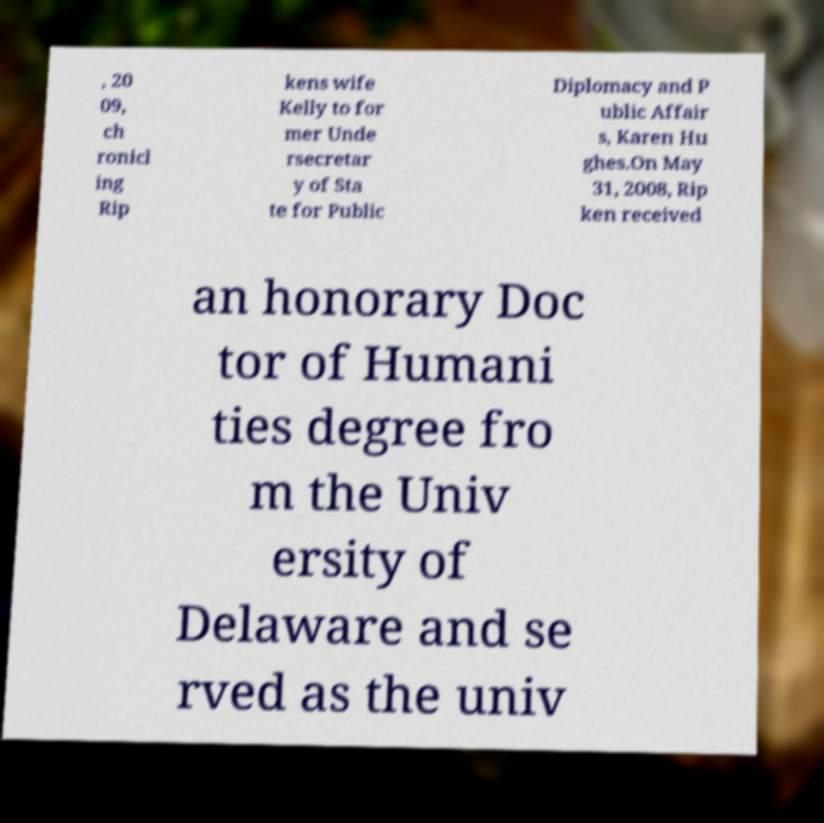For documentation purposes, I need the text within this image transcribed. Could you provide that? , 20 09, ch ronicl ing Rip kens wife Kelly to for mer Unde rsecretar y of Sta te for Public Diplomacy and P ublic Affair s, Karen Hu ghes.On May 31, 2008, Rip ken received an honorary Doc tor of Humani ties degree fro m the Univ ersity of Delaware and se rved as the univ 